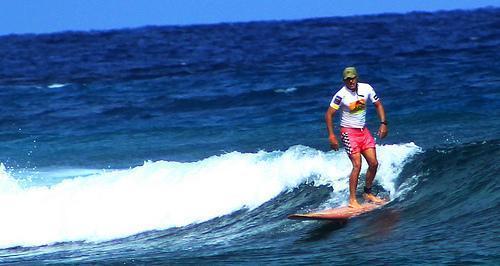How many waves is he surfing?
Give a very brief answer. 1. 